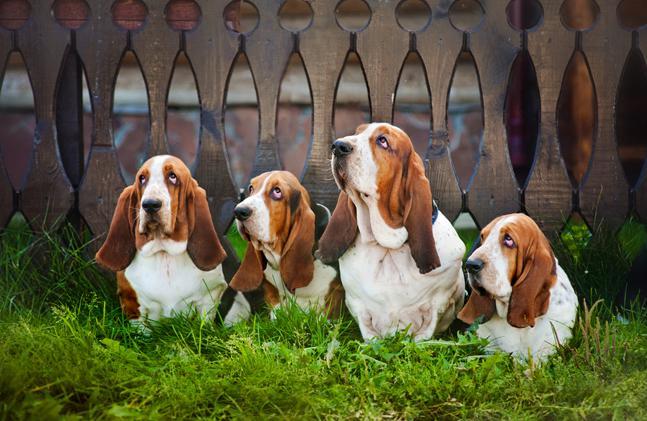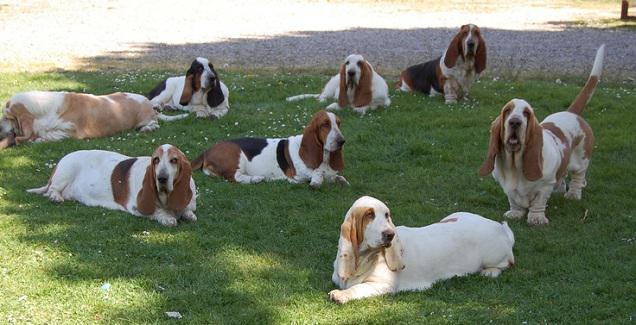The first image is the image on the left, the second image is the image on the right. Analyze the images presented: Is the assertion "All dogs are moving away from the camera in one image." valid? Answer yes or no. No. The first image is the image on the left, the second image is the image on the right. Given the left and right images, does the statement "Dogs are playing in at least one of the images." hold true? Answer yes or no. No. 